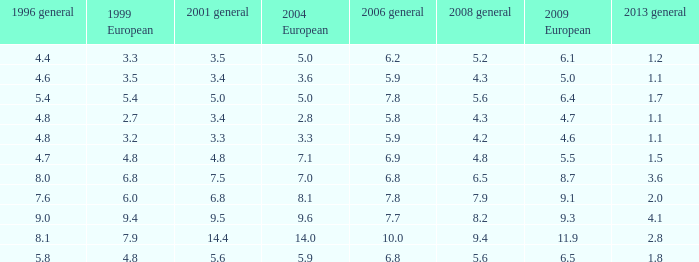8 in 1999 european, None. 